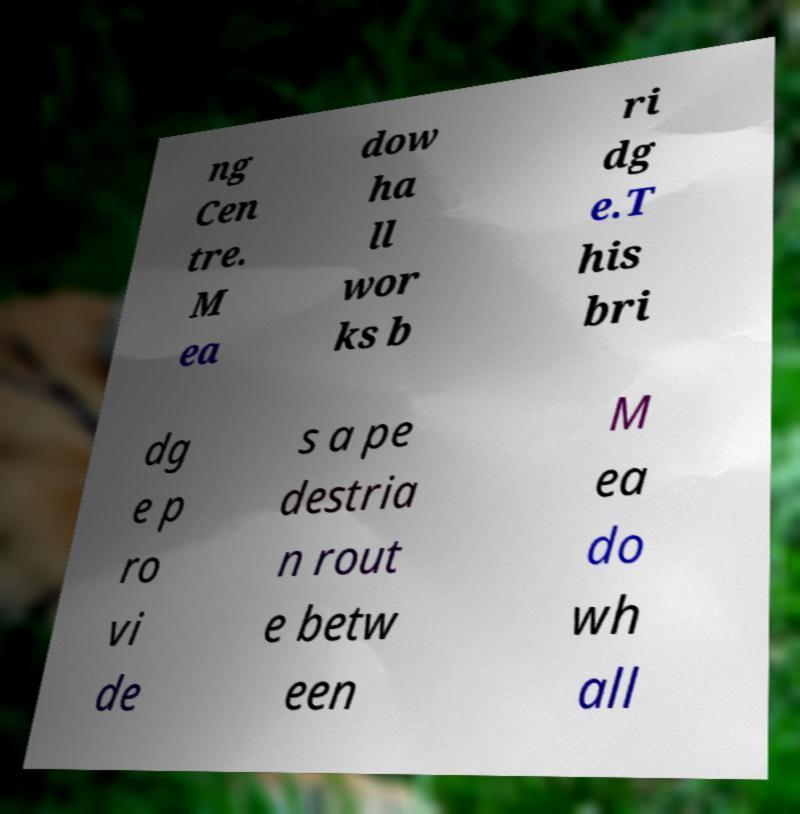Please read and relay the text visible in this image. What does it say? ng Cen tre. M ea dow ha ll wor ks b ri dg e.T his bri dg e p ro vi de s a pe destria n rout e betw een M ea do wh all 